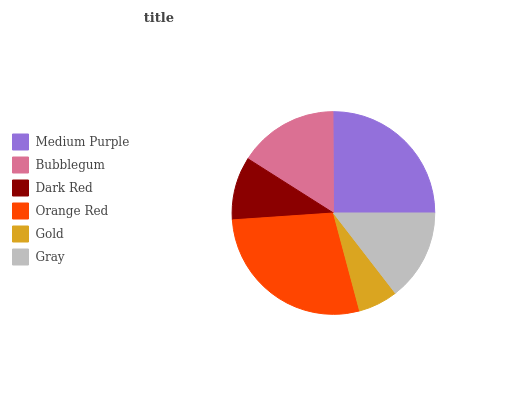Is Gold the minimum?
Answer yes or no. Yes. Is Orange Red the maximum?
Answer yes or no. Yes. Is Bubblegum the minimum?
Answer yes or no. No. Is Bubblegum the maximum?
Answer yes or no. No. Is Medium Purple greater than Bubblegum?
Answer yes or no. Yes. Is Bubblegum less than Medium Purple?
Answer yes or no. Yes. Is Bubblegum greater than Medium Purple?
Answer yes or no. No. Is Medium Purple less than Bubblegum?
Answer yes or no. No. Is Bubblegum the high median?
Answer yes or no. Yes. Is Gray the low median?
Answer yes or no. Yes. Is Medium Purple the high median?
Answer yes or no. No. Is Orange Red the low median?
Answer yes or no. No. 